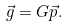<formula> <loc_0><loc_0><loc_500><loc_500>\vec { g } = G \vec { p } .</formula> 